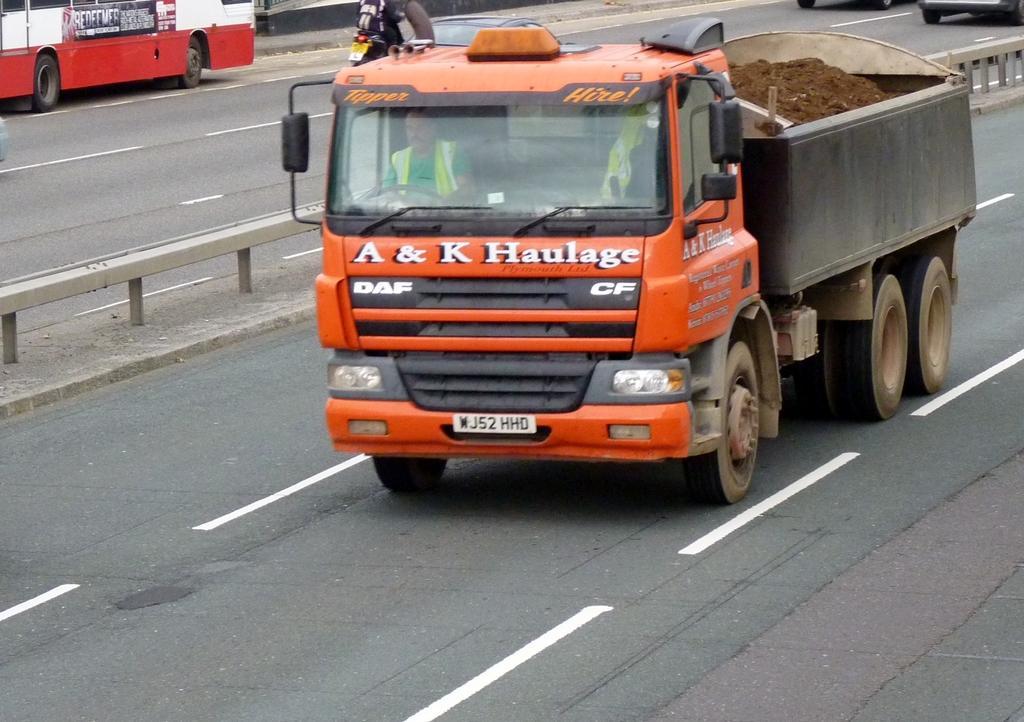Describe this image in one or two sentences. This picture is taken on the road. In this image, in the middle, we can see a vehicle which is moving on the road. In the vehicle, we can see a man sitting riding a vehicle. on the vehicle, we can also see some sand. On the left side, we can see a bus which is on the road. On the left side, we can also see a bike. In the background, we can see two vehicles which are moving on the road. At the bottom, we can see a road with white lines. 